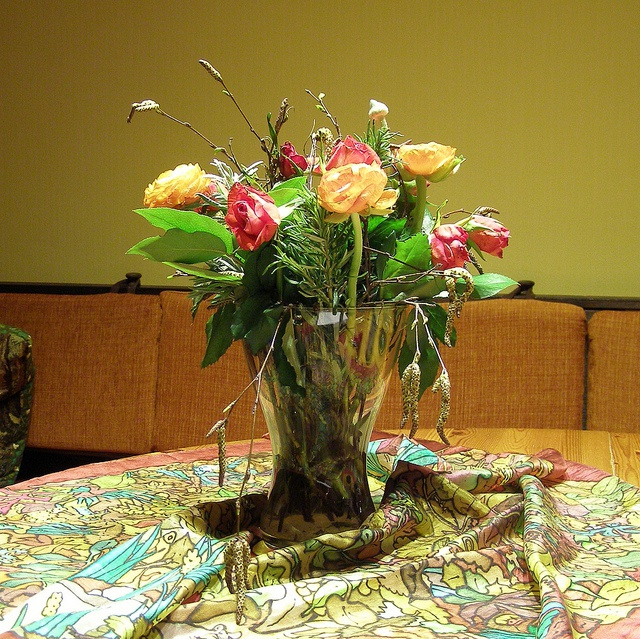Describe the objects in this image and their specific colors. I can see dining table in maroon, khaki, beige, tan, and olive tones, couch in maroon, brown, and black tones, and vase in maroon, black, and olive tones in this image. 